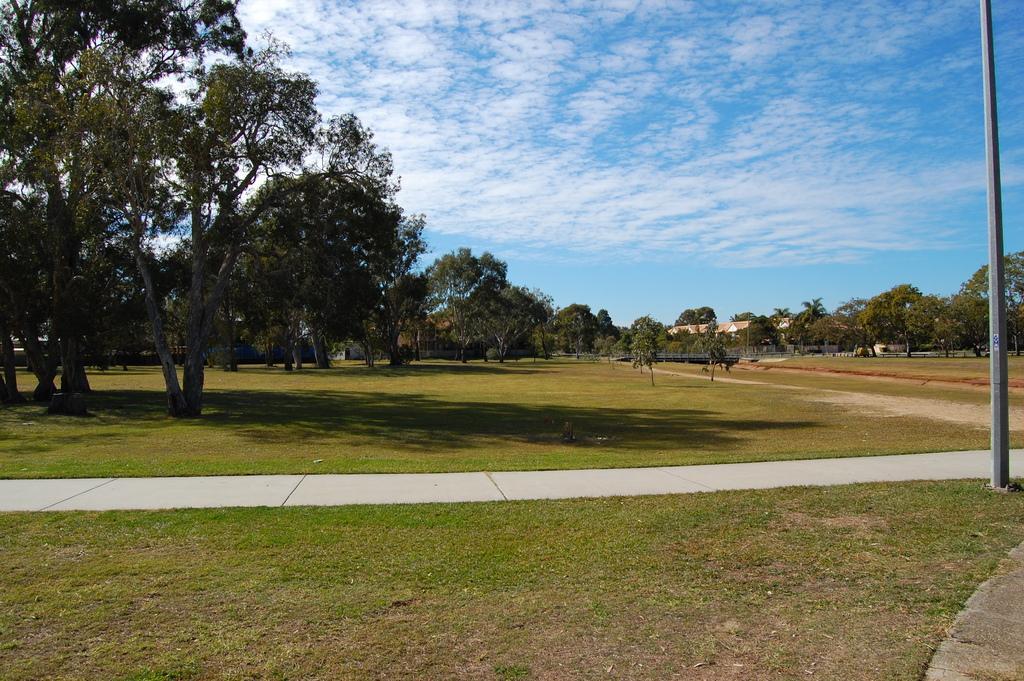What type of surface can be seen in the image? There is ground visible in the image. What type of vegetation is present in the image? There are trees in the image. What is the condition of the sky in the image? The sky is clear in the image. Where is the advertisement for baby steps located in the image? There is no advertisement or mention of baby steps in the image. How many babies are visible in the image? There are no babies present in the image. 